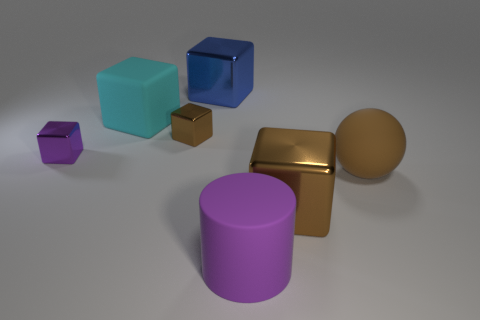Add 1 large purple cylinders. How many objects exist? 8 Subtract all purple metallic blocks. How many blocks are left? 4 Subtract all cubes. How many objects are left? 2 Subtract all blue blocks. How many blocks are left? 4 Subtract 1 cyan cubes. How many objects are left? 6 Subtract all green balls. Subtract all brown cubes. How many balls are left? 1 Subtract all brown cylinders. How many cyan balls are left? 0 Subtract all big balls. Subtract all blue metallic things. How many objects are left? 5 Add 6 cyan rubber things. How many cyan rubber things are left? 7 Add 3 large blue metal objects. How many large blue metal objects exist? 4 